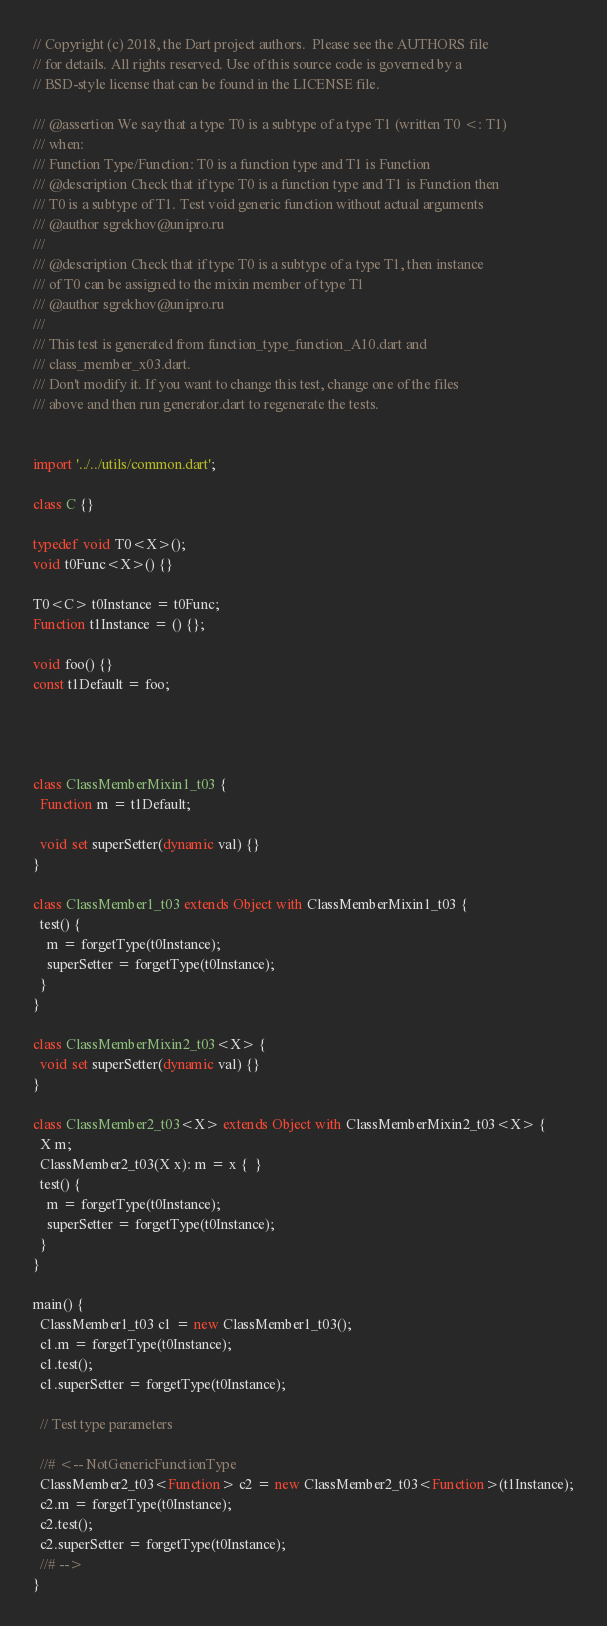<code> <loc_0><loc_0><loc_500><loc_500><_Dart_>// Copyright (c) 2018, the Dart project authors.  Please see the AUTHORS file
// for details. All rights reserved. Use of this source code is governed by a
// BSD-style license that can be found in the LICENSE file.

/// @assertion We say that a type T0 is a subtype of a type T1 (written T0 <: T1)
/// when:
/// Function Type/Function: T0 is a function type and T1 is Function
/// @description Check that if type T0 is a function type and T1 is Function then
/// T0 is a subtype of T1. Test void generic function without actual arguments
/// @author sgrekhov@unipro.ru
///
/// @description Check that if type T0 is a subtype of a type T1, then instance
/// of T0 can be assigned to the mixin member of type T1
/// @author sgrekhov@unipro.ru
///
/// This test is generated from function_type_function_A10.dart and 
/// class_member_x03.dart.
/// Don't modify it. If you want to change this test, change one of the files 
/// above and then run generator.dart to regenerate the tests.


import '../../utils/common.dart';

class C {}

typedef void T0<X>();
void t0Func<X>() {}

T0<C> t0Instance = t0Func;
Function t1Instance = () {};

void foo() {}
const t1Default = foo;




class ClassMemberMixin1_t03 {
  Function m = t1Default;

  void set superSetter(dynamic val) {}
}

class ClassMember1_t03 extends Object with ClassMemberMixin1_t03 {
  test() {
    m = forgetType(t0Instance);
    superSetter = forgetType(t0Instance);
  }
}

class ClassMemberMixin2_t03<X> {
  void set superSetter(dynamic val) {}
}

class ClassMember2_t03<X> extends Object with ClassMemberMixin2_t03<X> {
  X m;
  ClassMember2_t03(X x): m = x {  }
  test() {
    m = forgetType(t0Instance);
    superSetter = forgetType(t0Instance);
  }
}

main() {
  ClassMember1_t03 c1 = new ClassMember1_t03();
  c1.m = forgetType(t0Instance);
  c1.test();
  c1.superSetter = forgetType(t0Instance);

  // Test type parameters

  //# <-- NotGenericFunctionType
  ClassMember2_t03<Function> c2 = new ClassMember2_t03<Function>(t1Instance);
  c2.m = forgetType(t0Instance);
  c2.test();
  c2.superSetter = forgetType(t0Instance);
  //# -->
}
</code> 